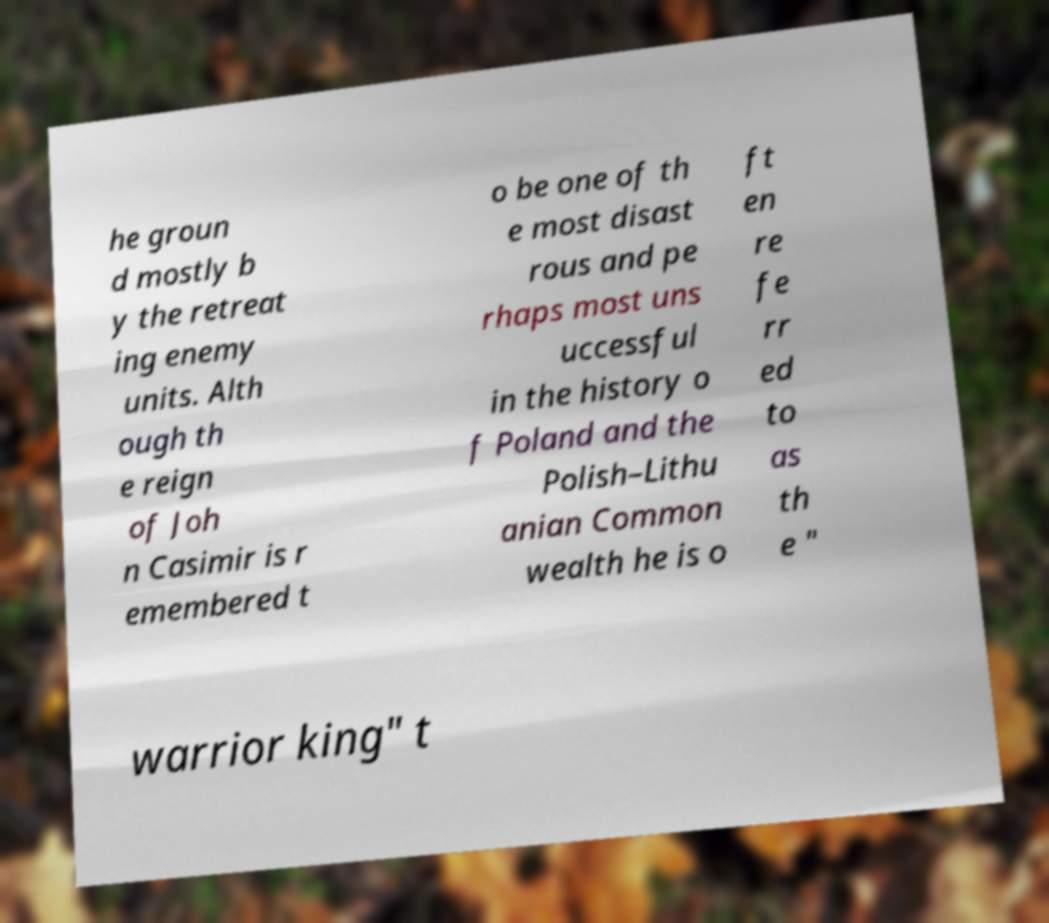Please read and relay the text visible in this image. What does it say? he groun d mostly b y the retreat ing enemy units. Alth ough th e reign of Joh n Casimir is r emembered t o be one of th e most disast rous and pe rhaps most uns uccessful in the history o f Poland and the Polish–Lithu anian Common wealth he is o ft en re fe rr ed to as th e " warrior king" t 